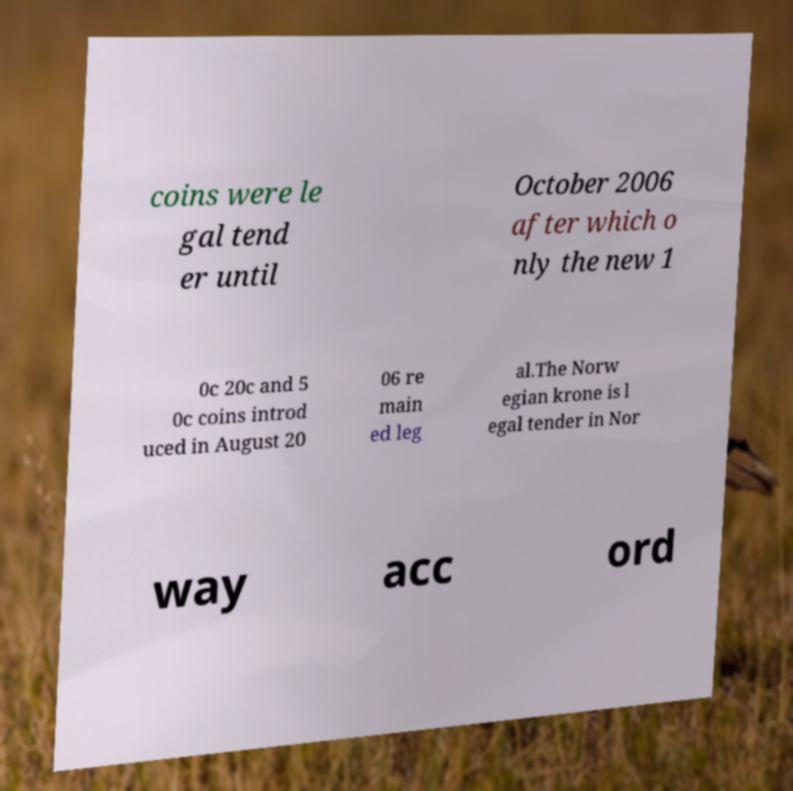For documentation purposes, I need the text within this image transcribed. Could you provide that? coins were le gal tend er until October 2006 after which o nly the new 1 0c 20c and 5 0c coins introd uced in August 20 06 re main ed leg al.The Norw egian krone is l egal tender in Nor way acc ord 